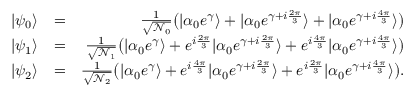Convert formula to latex. <formula><loc_0><loc_0><loc_500><loc_500>\begin{array} { r l r } { | \psi _ { 0 } \rangle } & { = } & { \frac { 1 } { \sqrt { \mathcal { N } _ { 0 } } } \left ( | \alpha _ { 0 } e ^ { \gamma } \rangle + | \alpha _ { 0 } e ^ { \gamma + i \frac { 2 \pi } { 3 } } \rangle + | \alpha _ { 0 } e ^ { \gamma + i \frac { 4 \pi } { 3 } } \rangle \right ) } \\ { | \psi _ { 1 } \rangle } & { = } & { \frac { 1 } { \sqrt { \mathcal { N } _ { 1 } } } \left ( | \alpha _ { 0 } e ^ { \gamma } \rangle + e ^ { i \frac { 2 \pi } { 3 } } | \alpha _ { 0 } e ^ { \gamma + i \frac { 2 \pi } { 3 } } \rangle + e ^ { i \frac { 4 \pi } { 3 } } | \alpha _ { 0 } e ^ { \gamma + i \frac { 4 \pi } { 3 } } \rangle \right ) } \\ { | \psi _ { 2 } \rangle } & { = } & { \frac { 1 } { \sqrt { \mathcal { N } _ { 2 } } } \left ( | \alpha _ { 0 } e ^ { \gamma } \rangle + e ^ { i \frac { 4 \pi } { 3 } } | \alpha _ { 0 } e ^ { \gamma + i \frac { 2 \pi } { 3 } } \rangle + e ^ { i \frac { 2 \pi } { 3 } } | \alpha _ { 0 } e ^ { \gamma + i \frac { 4 \pi } { 3 } } \rangle \right ) . } \end{array}</formula> 